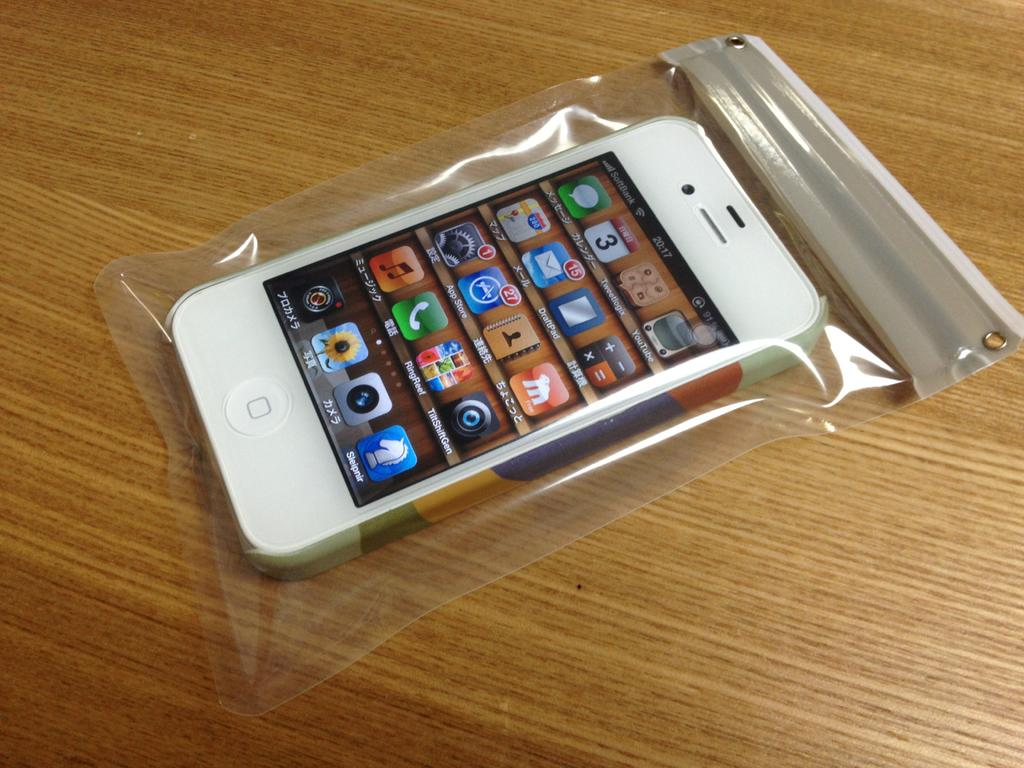Provide a one-sentence caption for the provided image. A phone in a bag has service from SoftBank. 